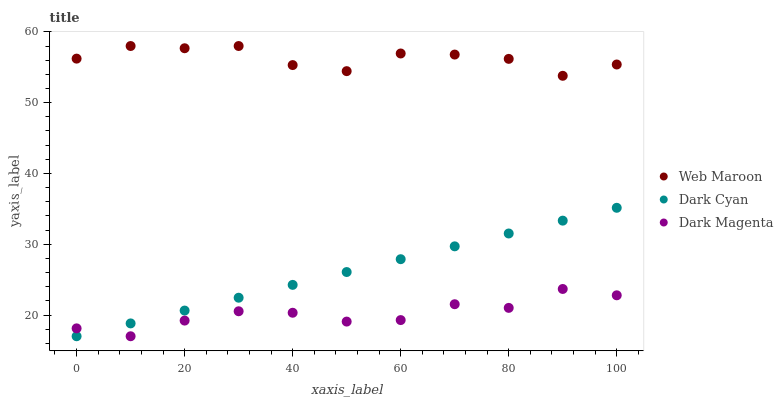Does Dark Magenta have the minimum area under the curve?
Answer yes or no. Yes. Does Web Maroon have the maximum area under the curve?
Answer yes or no. Yes. Does Web Maroon have the minimum area under the curve?
Answer yes or no. No. Does Dark Magenta have the maximum area under the curve?
Answer yes or no. No. Is Dark Cyan the smoothest?
Answer yes or no. Yes. Is Web Maroon the roughest?
Answer yes or no. Yes. Is Dark Magenta the smoothest?
Answer yes or no. No. Is Dark Magenta the roughest?
Answer yes or no. No. Does Dark Cyan have the lowest value?
Answer yes or no. Yes. Does Web Maroon have the lowest value?
Answer yes or no. No. Does Web Maroon have the highest value?
Answer yes or no. Yes. Does Dark Magenta have the highest value?
Answer yes or no. No. Is Dark Cyan less than Web Maroon?
Answer yes or no. Yes. Is Web Maroon greater than Dark Cyan?
Answer yes or no. Yes. Does Dark Cyan intersect Dark Magenta?
Answer yes or no. Yes. Is Dark Cyan less than Dark Magenta?
Answer yes or no. No. Is Dark Cyan greater than Dark Magenta?
Answer yes or no. No. Does Dark Cyan intersect Web Maroon?
Answer yes or no. No. 